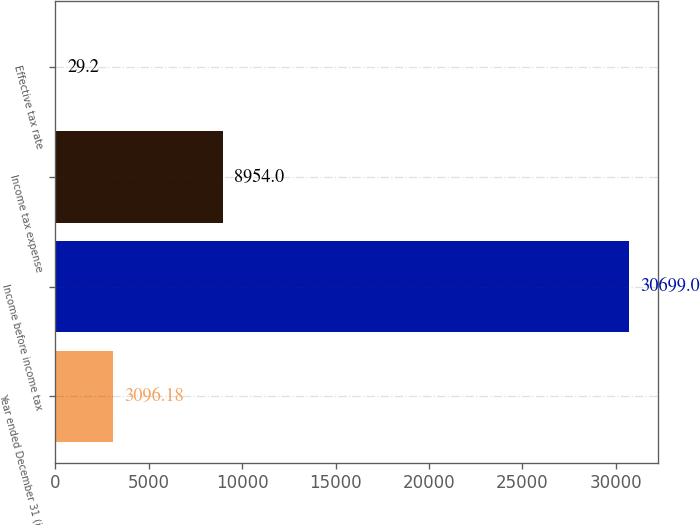<chart> <loc_0><loc_0><loc_500><loc_500><bar_chart><fcel>Year ended December 31 (in<fcel>Income before income tax<fcel>Income tax expense<fcel>Effective tax rate<nl><fcel>3096.18<fcel>30699<fcel>8954<fcel>29.2<nl></chart> 